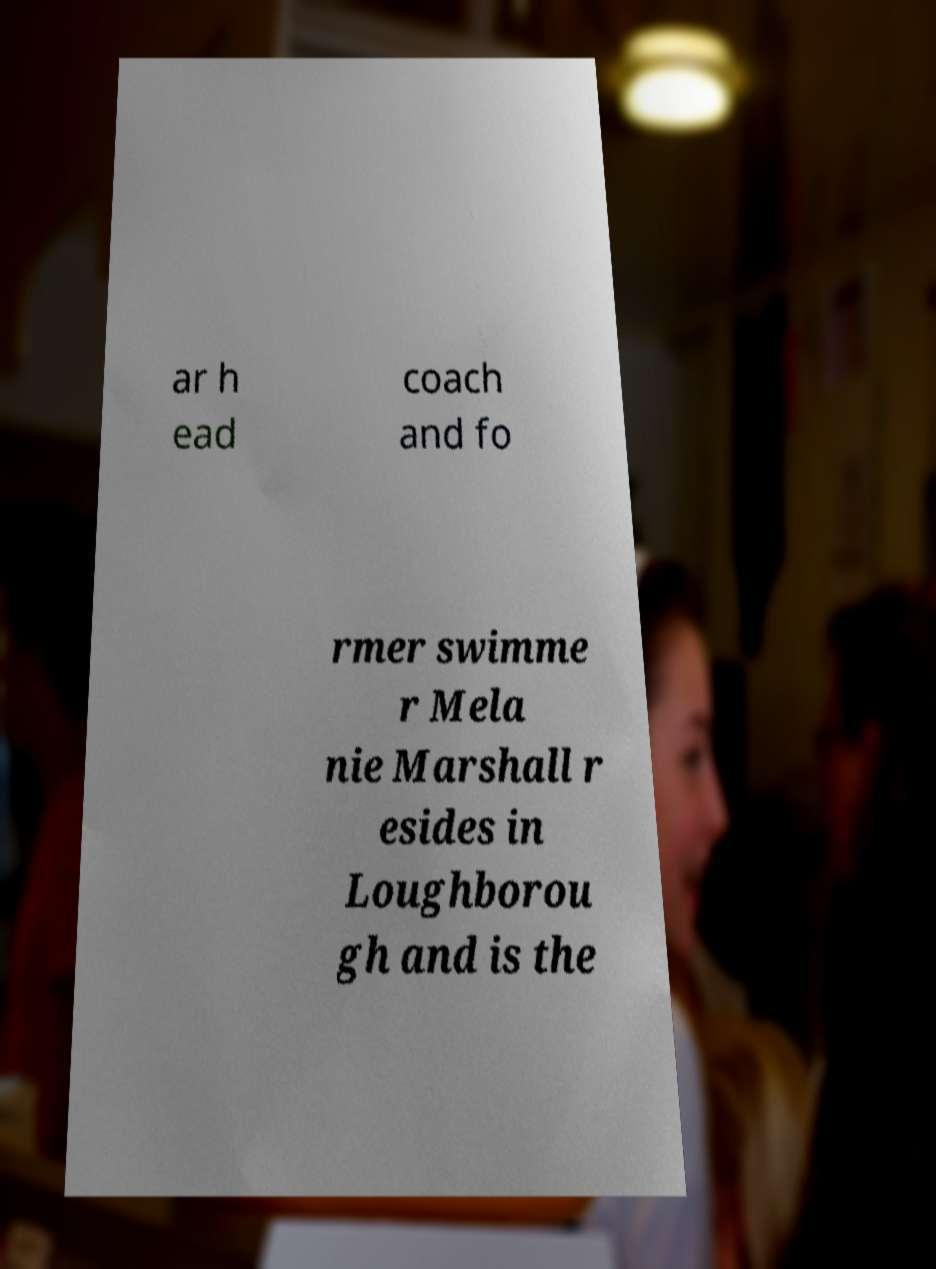Can you read and provide the text displayed in the image?This photo seems to have some interesting text. Can you extract and type it out for me? ar h ead coach and fo rmer swimme r Mela nie Marshall r esides in Loughborou gh and is the 